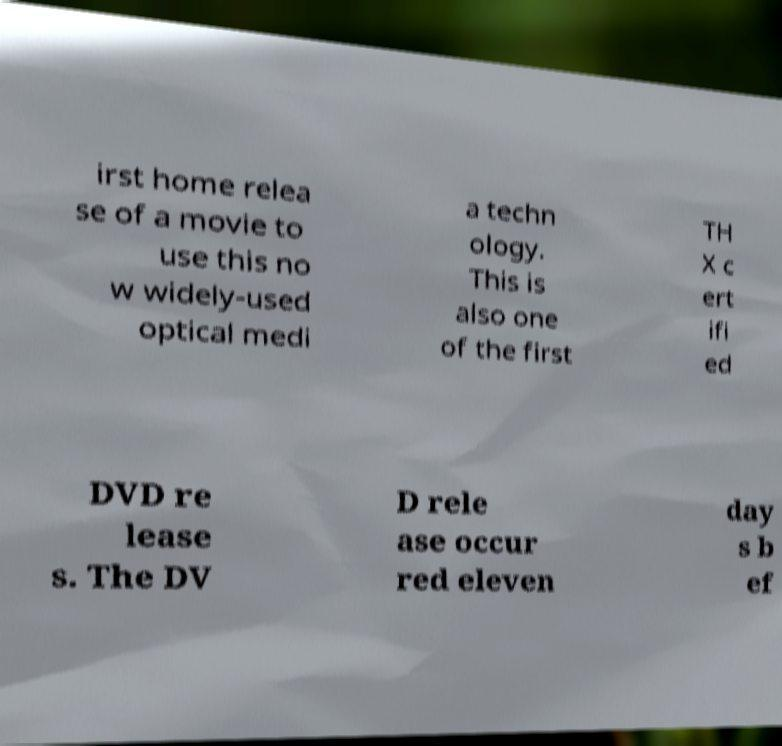Could you assist in decoding the text presented in this image and type it out clearly? irst home relea se of a movie to use this no w widely-used optical medi a techn ology. This is also one of the first TH X c ert ifi ed DVD re lease s. The DV D rele ase occur red eleven day s b ef 